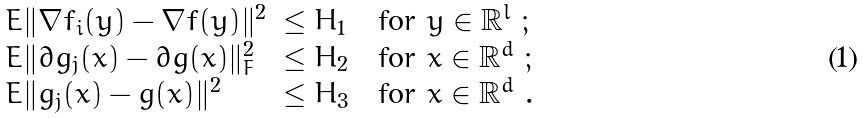Convert formula to latex. <formula><loc_0><loc_0><loc_500><loc_500>\begin{array} { l l l } E \| \nabla f _ { i } ( y ) - \nabla f ( y ) \| ^ { 2 } & \leq H _ { 1 } & \text { for } y \in \mathbb { R } ^ { l } \ ; \\ E \| \partial g _ { j } ( x ) - \partial g ( x ) \| _ { F } ^ { 2 } & \leq H _ { 2 } & \text { for } x \in \mathbb { R } ^ { d } \ ; \\ E \| g _ { j } ( x ) - g ( x ) \| ^ { 2 } & \leq H _ { 3 } & \text { for } x \in \mathbb { R } ^ { d } \ . \end{array}</formula> 